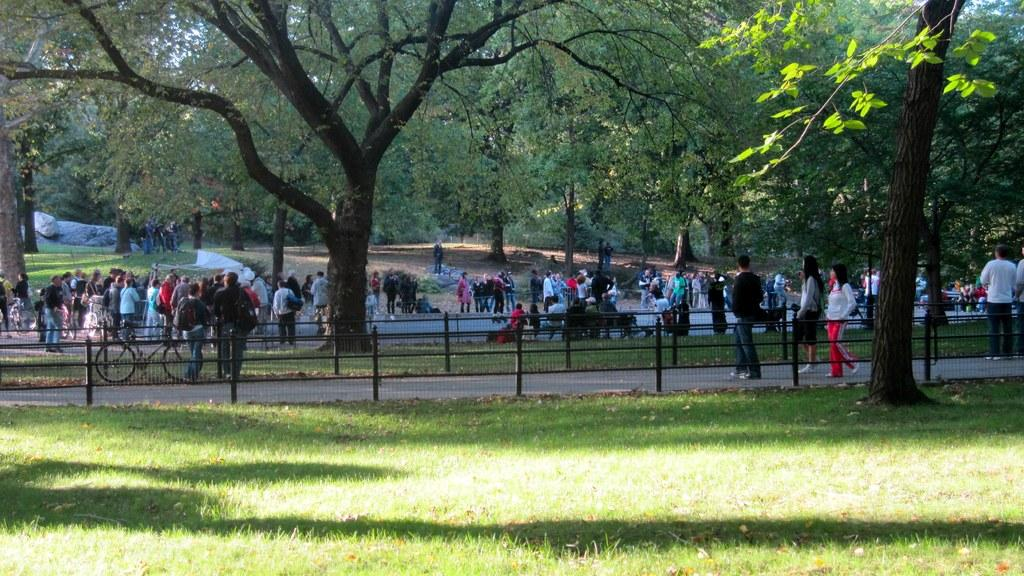What type of vegetation is at the bottom of the image? There is grass at the bottom of the image. What can be seen in the background of the image? There is a fence, trees, and a group of people in the background of the image. Where is the bicycle located in the image? The bicycle is on the left side of the image. How does the honey look like in the image? There is no honey present in the image. Can you see any bees flying around the trees in the image? There is no mention of bees in the image, only trees and a group of people. 